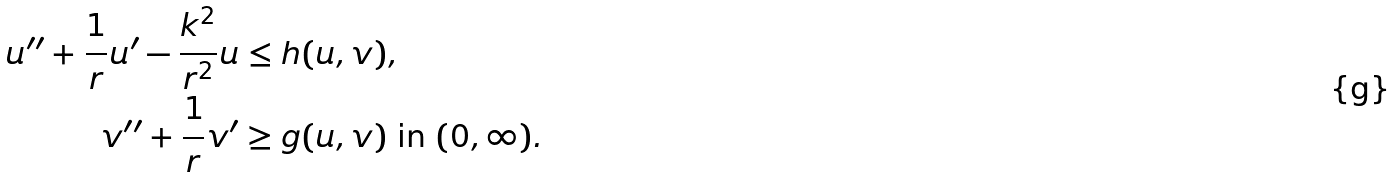Convert formula to latex. <formula><loc_0><loc_0><loc_500><loc_500>u ^ { \prime \prime } + \frac { 1 } { r } u ^ { \prime } - \frac { k ^ { 2 } } { r ^ { 2 } } u & \leq h ( u , v ) , \\ v ^ { \prime \prime } + \frac { 1 } { r } v ^ { \prime } & \geq g ( u , v ) \text { in } ( 0 , \infty ) .</formula> 